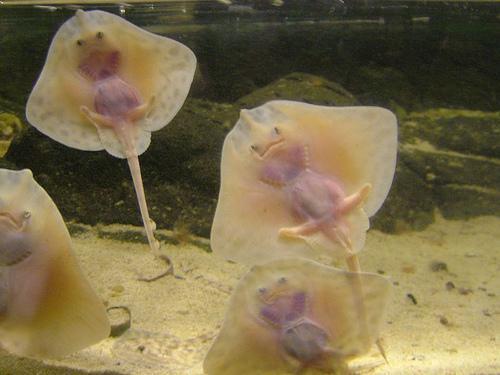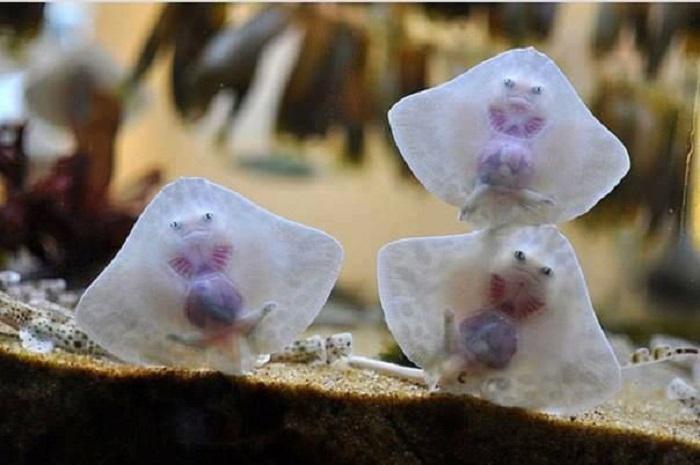The first image is the image on the left, the second image is the image on the right. For the images shown, is this caption "There are more than 2 rays." true? Answer yes or no. Yes. The first image is the image on the left, the second image is the image on the right. Given the left and right images, does the statement "There are more rays in the image on the left than in the image on the right." hold true? Answer yes or no. Yes. 